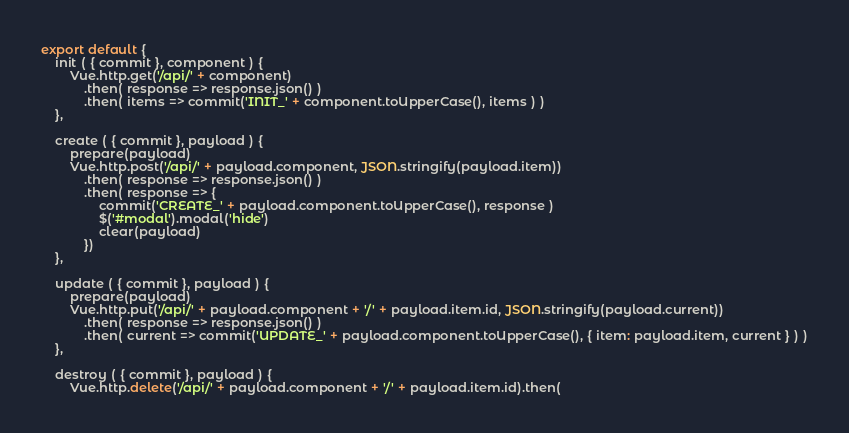<code> <loc_0><loc_0><loc_500><loc_500><_JavaScript_>export default {
    init ( { commit }, component ) {
        Vue.http.get('/api/' + component)
            .then( response => response.json() )
            .then( items => commit('INIT_' + component.toUpperCase(), items ) )
    },

    create ( { commit }, payload ) {
        prepare(payload)
        Vue.http.post('/api/' + payload.component, JSON.stringify(payload.item))
            .then( response => response.json() )
            .then( response => {
                commit('CREATE_' + payload.component.toUpperCase(), response )
                $('#modal').modal('hide')
                clear(payload)
            })
    },

    update ( { commit }, payload ) {
        prepare(payload)
        Vue.http.put('/api/' + payload.component + '/' + payload.item.id, JSON.stringify(payload.current))
            .then( response => response.json() )
            .then( current => commit('UPDATE_' + payload.component.toUpperCase(), { item: payload.item, current } ) )
    },

    destroy ( { commit }, payload ) {
        Vue.http.delete('/api/' + payload.component + '/' + payload.item.id).then(</code> 